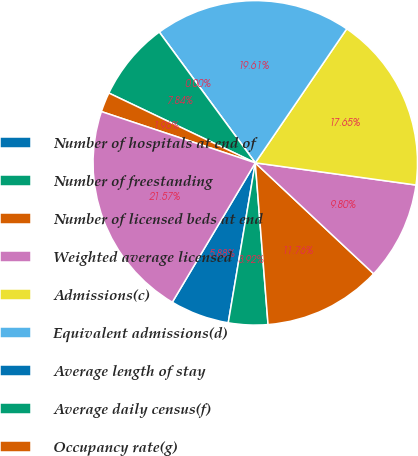<chart> <loc_0><loc_0><loc_500><loc_500><pie_chart><fcel>Number of hospitals at end of<fcel>Number of freestanding<fcel>Number of licensed beds at end<fcel>Weighted average licensed<fcel>Admissions(c)<fcel>Equivalent admissions(d)<fcel>Average length of stay<fcel>Average daily census(f)<fcel>Occupancy rate(g)<fcel>Emergency room visits(h)<nl><fcel>5.88%<fcel>3.92%<fcel>11.76%<fcel>9.8%<fcel>17.65%<fcel>19.61%<fcel>0.0%<fcel>7.84%<fcel>1.96%<fcel>21.57%<nl></chart> 